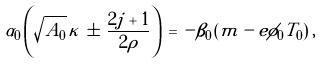<formula> <loc_0><loc_0><loc_500><loc_500>\alpha _ { 0 } \left ( \sqrt { A _ { 0 } } \, \kappa \, \pm \, \frac { 2 j + 1 } { 2 \rho } \right ) \, = \, - \beta _ { 0 } \, ( m - e \phi _ { 0 } T _ { 0 } ) \, ,</formula> 